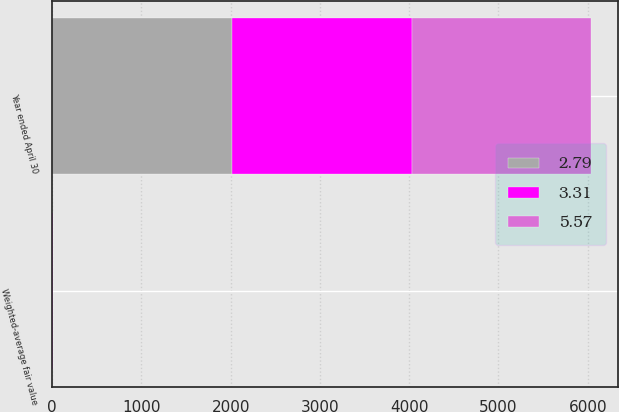<chart> <loc_0><loc_0><loc_500><loc_500><stacked_bar_chart><ecel><fcel>Year ended April 30<fcel>Weighted-average fair value<nl><fcel>3.31<fcel>2014<fcel>5.57<nl><fcel>2.79<fcel>2013<fcel>2.79<nl><fcel>5.57<fcel>2012<fcel>3.31<nl></chart> 